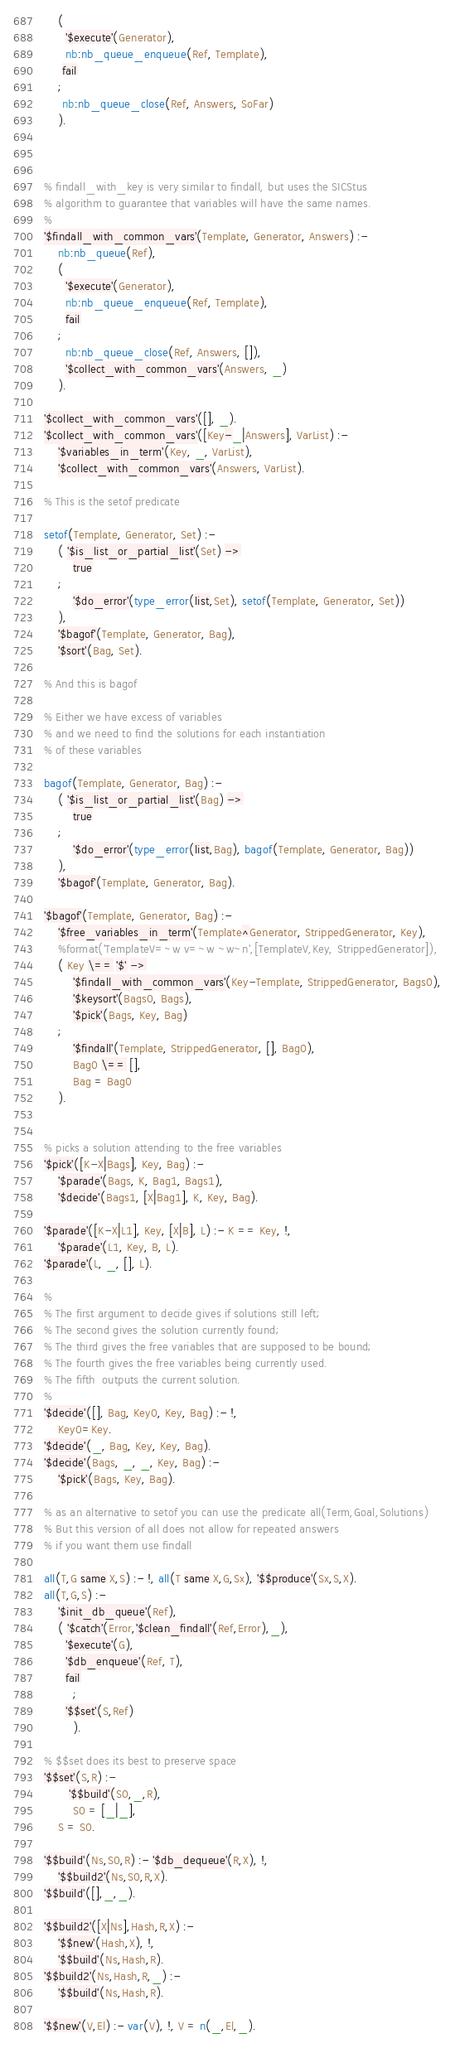Convert code to text. <code><loc_0><loc_0><loc_500><loc_500><_Prolog_>	(
	  '$execute'(Generator),
	  nb:nb_queue_enqueue(Ref, Template),
	 fail
	;
	 nb:nb_queue_close(Ref, Answers, SoFar)
	).



% findall_with_key is very similar to findall, but uses the SICStus
% algorithm to guarantee that variables will have the same names.
%
'$findall_with_common_vars'(Template, Generator, Answers) :-
	nb:nb_queue(Ref),
	(
	  '$execute'(Generator),
	  nb:nb_queue_enqueue(Ref, Template),
	  fail
	;
	  nb:nb_queue_close(Ref, Answers, []),
	  '$collect_with_common_vars'(Answers, _)
	).

'$collect_with_common_vars'([], _).
'$collect_with_common_vars'([Key-_|Answers], VarList) :-
	'$variables_in_term'(Key, _, VarList),
	'$collect_with_common_vars'(Answers, VarList).
	
% This is the setof predicate

setof(Template, Generator, Set) :-
	( '$is_list_or_partial_list'(Set) ->
		true
	;
		'$do_error'(type_error(list,Set), setof(Template, Generator, Set))
	),
	'$bagof'(Template, Generator, Bag),
	'$sort'(Bag, Set).

% And this is bagof

% Either we have excess of variables
% and we need to find the solutions for each instantiation
% of these variables

bagof(Template, Generator, Bag) :-
	( '$is_list_or_partial_list'(Bag) ->
		true
	;
		'$do_error'(type_error(list,Bag), bagof(Template, Generator, Bag))
	),
	'$bagof'(Template, Generator, Bag).

'$bagof'(Template, Generator, Bag) :-
	'$free_variables_in_term'(Template^Generator, StrippedGenerator, Key),
	%format('TemplateV=~w v=~w ~w~n',[TemplateV,Key, StrippedGenerator]),
	( Key \== '$' ->
		'$findall_with_common_vars'(Key-Template, StrippedGenerator, Bags0),
		'$keysort'(Bags0, Bags),
		'$pick'(Bags, Key, Bag)
	;
		'$findall'(Template, StrippedGenerator, [], Bag0),
		Bag0 \== [],
		Bag = Bag0
	).


% picks a solution attending to the free variables
'$pick'([K-X|Bags], Key, Bag) :-
	'$parade'(Bags, K, Bag1, Bags1),
	'$decide'(Bags1, [X|Bag1], K, Key, Bag).

'$parade'([K-X|L1], Key, [X|B], L) :- K == Key, !,
	'$parade'(L1, Key, B, L).
'$parade'(L, _, [], L).

%
% The first argument to decide gives if solutions still left;
% The second gives the solution currently found;
% The third gives the free variables that are supposed to be bound;
% The fourth gives the free variables being currently used.
% The fifth  outputs the current solution.
%
'$decide'([], Bag, Key0, Key, Bag) :- !,
	Key0=Key.
'$decide'(_, Bag, Key, Key, Bag).
'$decide'(Bags, _, _, Key, Bag) :-
	'$pick'(Bags, Key, Bag).

% as an alternative to setof you can use the predicate all(Term,Goal,Solutions)
% But this version of all does not allow for repeated answers
% if you want them use findall	

all(T,G same X,S) :- !, all(T same X,G,Sx), '$$produce'(Sx,S,X).
all(T,G,S) :- 
	'$init_db_queue'(Ref),
	( '$catch'(Error,'$clean_findall'(Ref,Error),_),
	  '$execute'(G),
	  '$db_enqueue'(Ref, T),
	  fail
        ;
	  '$$set'(S,Ref)
        ).

% $$set does its best to preserve space
'$$set'(S,R) :- 
       '$$build'(S0,_,R),
        S0 = [_|_],
	S = S0.

'$$build'(Ns,S0,R) :- '$db_dequeue'(R,X), !,
	'$$build2'(Ns,S0,R,X).
'$$build'([],_,_).

'$$build2'([X|Ns],Hash,R,X) :-
	'$$new'(Hash,X), !,
	'$$build'(Ns,Hash,R).
'$$build2'(Ns,Hash,R,_) :-
	'$$build'(Ns,Hash,R).

'$$new'(V,El) :- var(V), !, V = n(_,El,_).</code> 